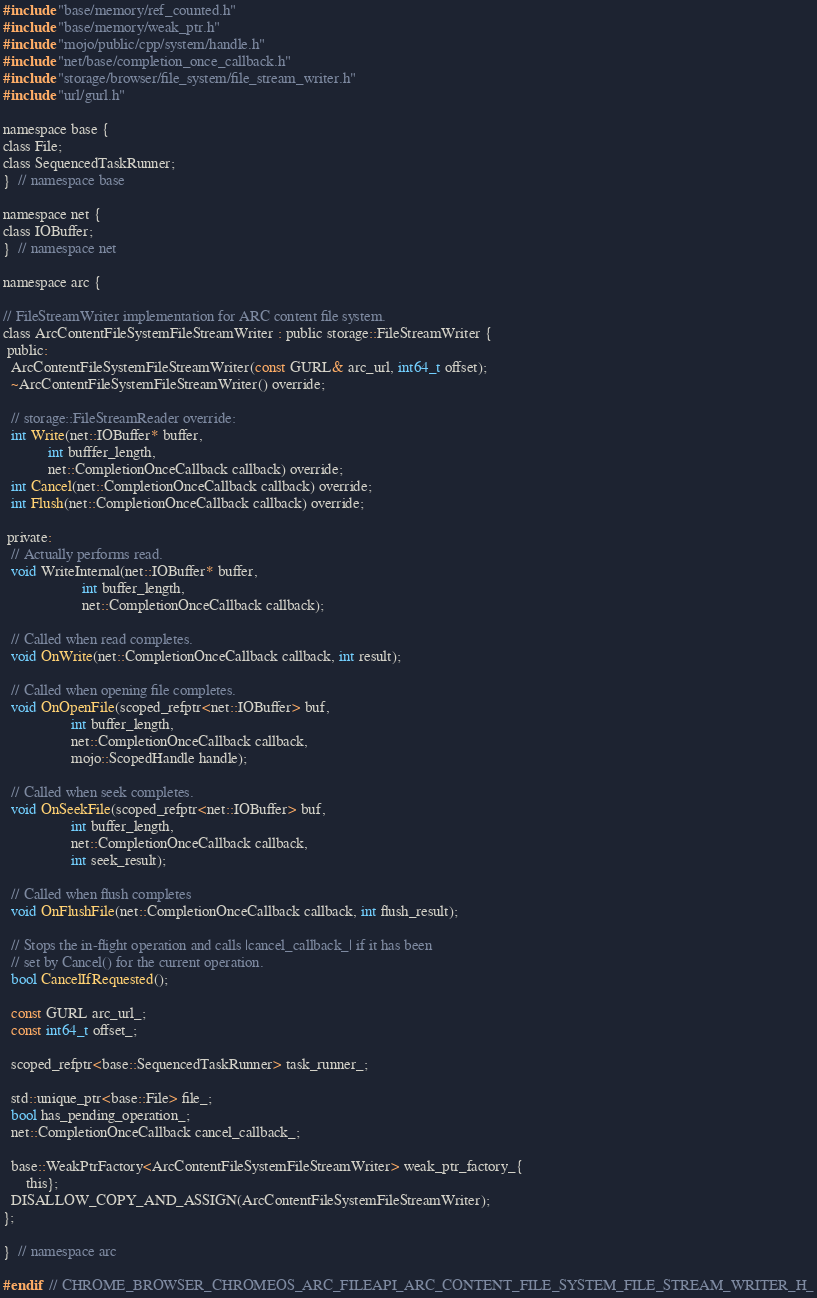<code> <loc_0><loc_0><loc_500><loc_500><_C_>#include "base/memory/ref_counted.h"
#include "base/memory/weak_ptr.h"
#include "mojo/public/cpp/system/handle.h"
#include "net/base/completion_once_callback.h"
#include "storage/browser/file_system/file_stream_writer.h"
#include "url/gurl.h"

namespace base {
class File;
class SequencedTaskRunner;
}  // namespace base

namespace net {
class IOBuffer;
}  // namespace net

namespace arc {

// FileStreamWriter implementation for ARC content file system.
class ArcContentFileSystemFileStreamWriter : public storage::FileStreamWriter {
 public:
  ArcContentFileSystemFileStreamWriter(const GURL& arc_url, int64_t offset);
  ~ArcContentFileSystemFileStreamWriter() override;

  // storage::FileStreamReader override:
  int Write(net::IOBuffer* buffer,
            int bufffer_length,
            net::CompletionOnceCallback callback) override;
  int Cancel(net::CompletionOnceCallback callback) override;
  int Flush(net::CompletionOnceCallback callback) override;

 private:
  // Actually performs read.
  void WriteInternal(net::IOBuffer* buffer,
                     int buffer_length,
                     net::CompletionOnceCallback callback);

  // Called when read completes.
  void OnWrite(net::CompletionOnceCallback callback, int result);

  // Called when opening file completes.
  void OnOpenFile(scoped_refptr<net::IOBuffer> buf,
                  int buffer_length,
                  net::CompletionOnceCallback callback,
                  mojo::ScopedHandle handle);

  // Called when seek completes.
  void OnSeekFile(scoped_refptr<net::IOBuffer> buf,
                  int buffer_length,
                  net::CompletionOnceCallback callback,
                  int seek_result);

  // Called when flush completes
  void OnFlushFile(net::CompletionOnceCallback callback, int flush_result);

  // Stops the in-flight operation and calls |cancel_callback_| if it has been
  // set by Cancel() for the current operation.
  bool CancelIfRequested();

  const GURL arc_url_;
  const int64_t offset_;

  scoped_refptr<base::SequencedTaskRunner> task_runner_;

  std::unique_ptr<base::File> file_;
  bool has_pending_operation_;
  net::CompletionOnceCallback cancel_callback_;

  base::WeakPtrFactory<ArcContentFileSystemFileStreamWriter> weak_ptr_factory_{
      this};
  DISALLOW_COPY_AND_ASSIGN(ArcContentFileSystemFileStreamWriter);
};

}  // namespace arc

#endif  // CHROME_BROWSER_CHROMEOS_ARC_FILEAPI_ARC_CONTENT_FILE_SYSTEM_FILE_STREAM_WRITER_H_
</code> 